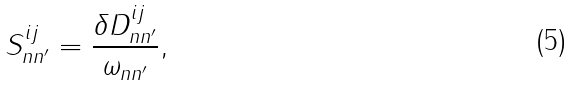<formula> <loc_0><loc_0><loc_500><loc_500>S ^ { i j } _ { n n ^ { \prime } } = \frac { \delta D ^ { i j } _ { n n ^ { \prime } } } { \omega _ { n n ^ { \prime } } } ,</formula> 